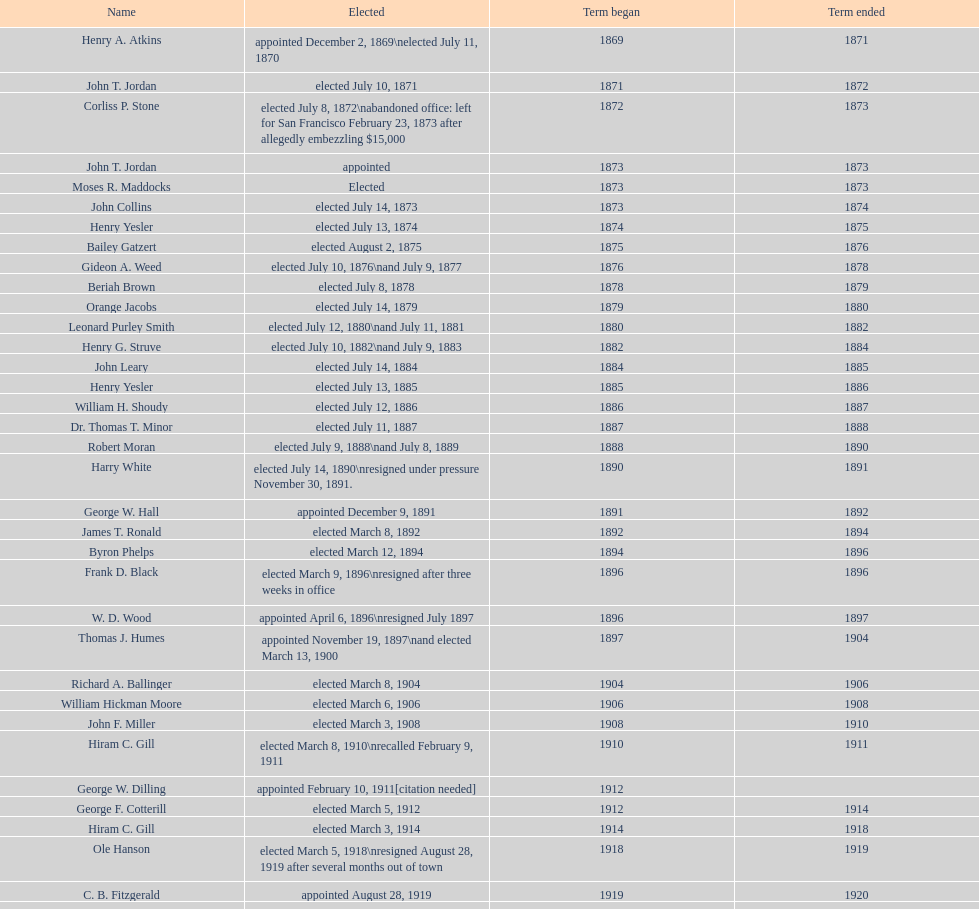Who served as the first mayor during the 1900s? Richard A. Ballinger. 